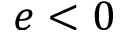<formula> <loc_0><loc_0><loc_500><loc_500>e < 0</formula> 